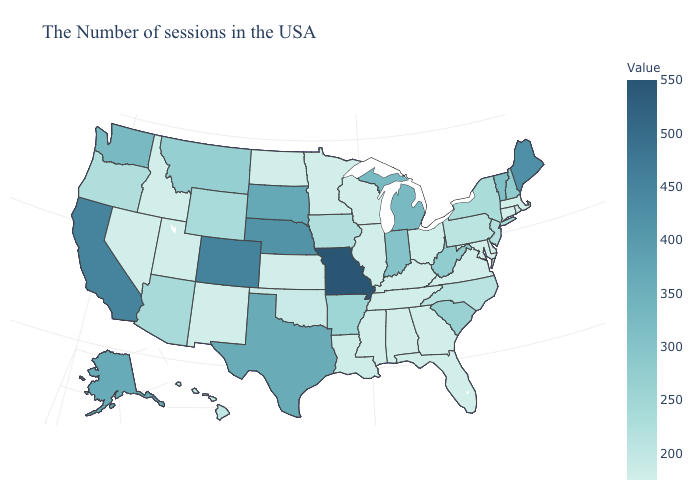Does the map have missing data?
Keep it brief. No. Which states have the lowest value in the USA?
Be succinct. Massachusetts, Rhode Island, Connecticut, Delaware, Maryland, Virginia, Florida, Georgia, Kentucky, Alabama, Tennessee, Wisconsin, Illinois, Mississippi, Minnesota, Kansas, North Dakota, New Mexico, Utah, Idaho, Nevada. Among the states that border Arkansas , which have the highest value?
Be succinct. Missouri. Does Ohio have the highest value in the MidWest?
Concise answer only. No. Is the legend a continuous bar?
Answer briefly. Yes. Among the states that border Delaware , does Pennsylvania have the lowest value?
Quick response, please. No. 